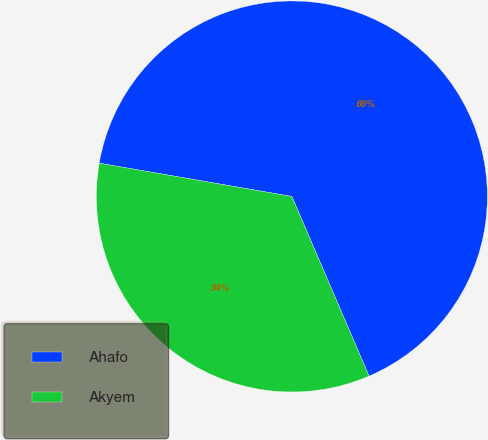Convert chart. <chart><loc_0><loc_0><loc_500><loc_500><pie_chart><fcel>Ahafo<fcel>Akyem<nl><fcel>65.82%<fcel>34.18%<nl></chart> 